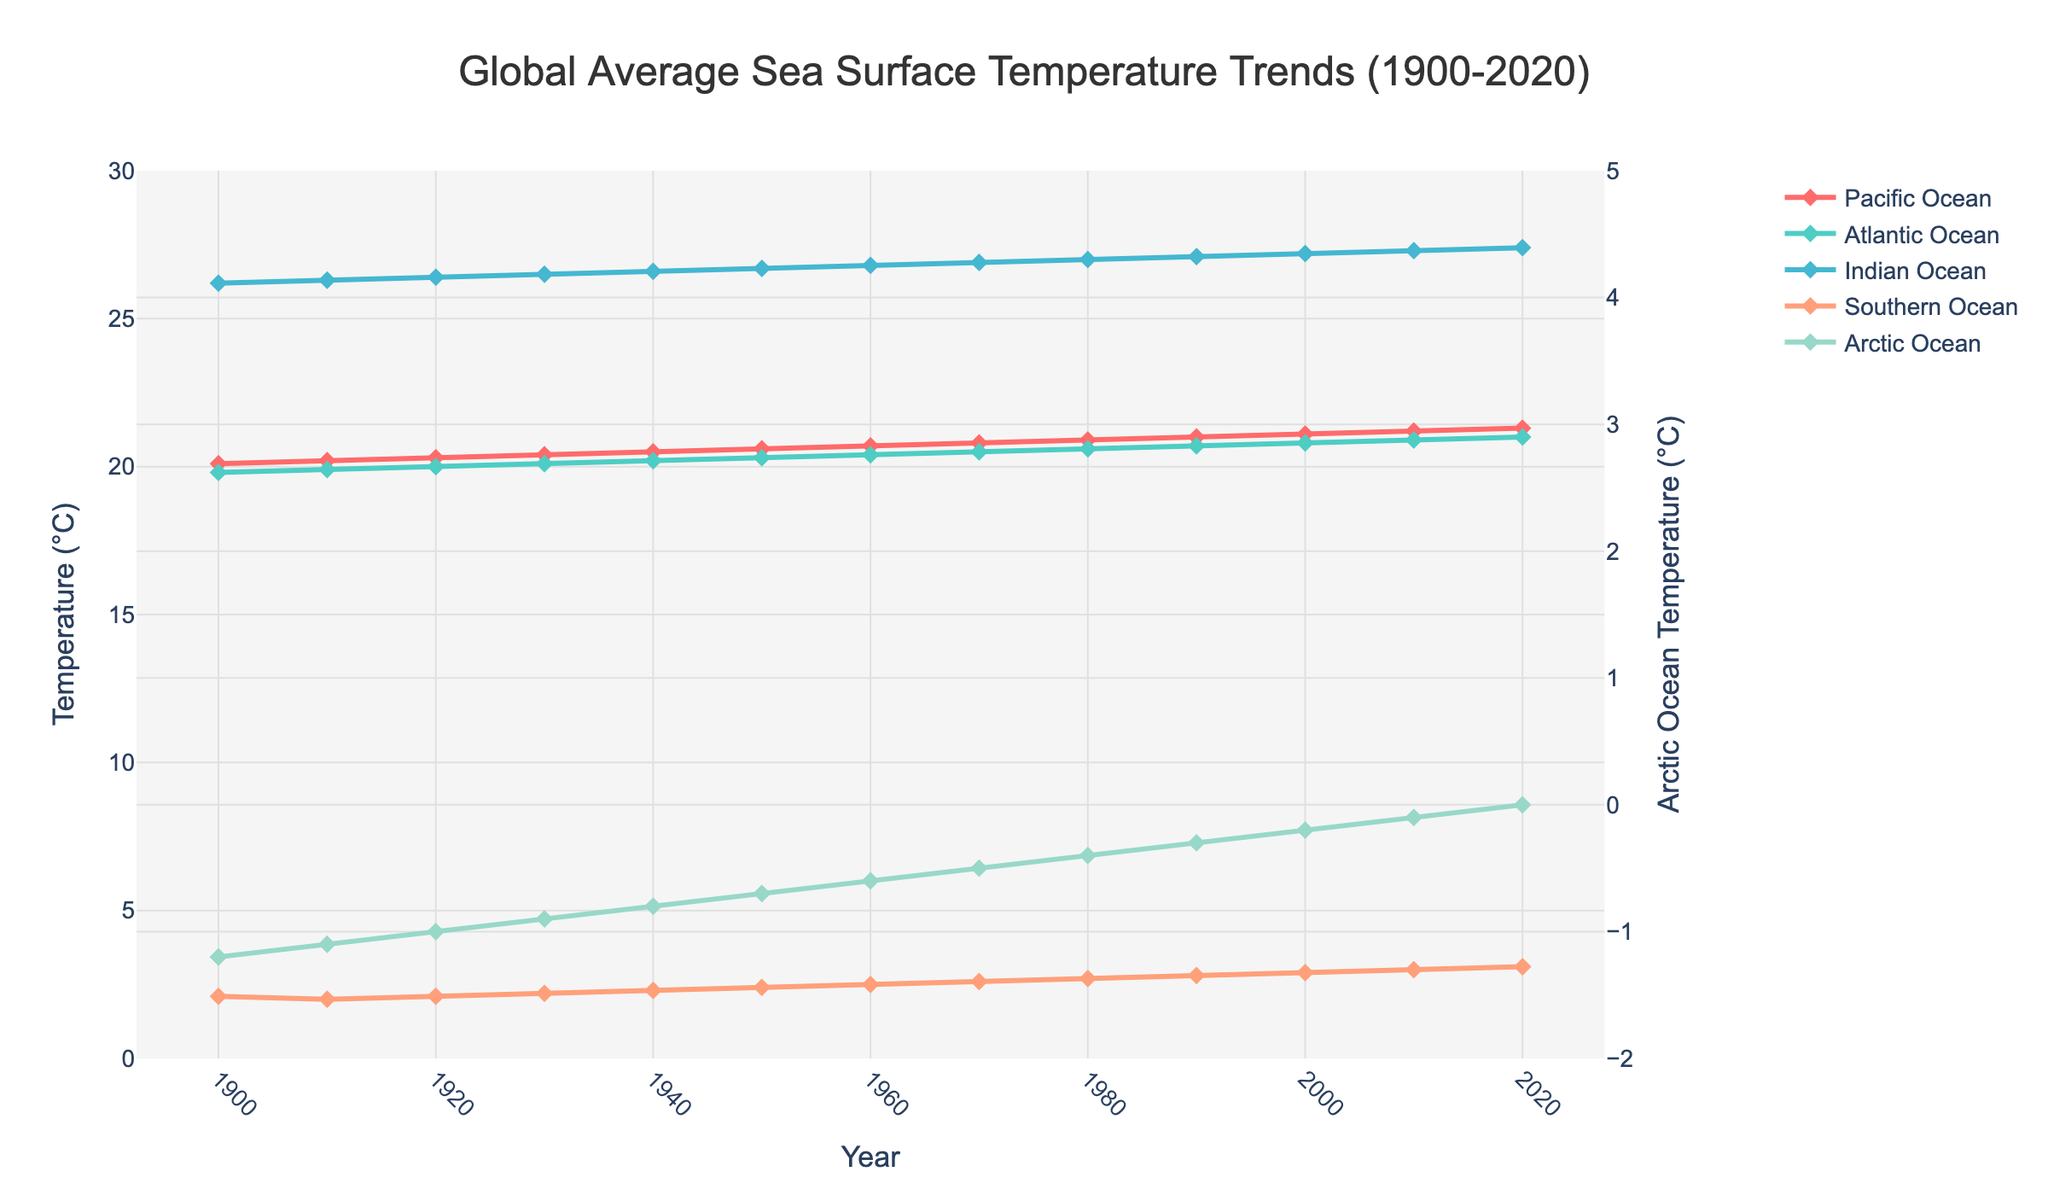Which ocean basin has the highest sea surface temperature increase from 1900 to 2020? Check the temperatures for all basins in both 1900 and 2020. Subtract the 2020 temperature from the 1900 temperature for each basin. The Indian Ocean shows an increase from 26.2°C to 27.4°C, which is 1.2°C, while other basins show lesser increases.
Answer: Indian Ocean Which ocean basin shows the least change in sea surface temperature from 1900 to 2020? Calculate the difference in temperature from 1900 to 2020 for each basin. The Arctic Ocean shows the least change with an increase from -1.2°C to 0°C, a difference of 1.2°C, which matches the smallest change among all oceans when compared with others.
Answer: Arctic Ocean (also has the smallest range) Which year did the Atlantic Ocean sea surface temperature surpass 20°C for the first time? Look at the Atlantic Ocean temperature trend and identify the first year the temperature exceeds 20°C. According to the data, it happened in 1920 when the temperature hits 20.0°C.
Answer: 1920 What is the average sea surface temperature for the Pacific Ocean across the entire dataset? Sum all the temperatures for the Pacific Ocean from 1900 to 2020 and then divide by the number of years (13). The data provided represents every 10 years, thus average = (20.1 + 20.2 + 20.3 + 20.4 + 20.5 + 20.6 + 20.7 + 20.8 + 20.9 + 21.0 + 21.1 + 21.2 + 21.3) / 13 = 270.1 / 13 = 20.777.
Answer: 20.78°C Which ocean basin has the steepest temperature increase based on visual slope? By observing the steepness of the temperature lines on the chart, the Southern Ocean has the steepest relative increase, showing a noticeable incline in its temperatures.
Answer: Southern Ocean In which year did the Arctic Ocean reach 0°C? Track the Arctic Ocean temperature trend and observe where it hits 0°C. According to the data, this occurs in 2020.
Answer: 2020 Which ocean shows the most stable temperature pattern over the century? "Stable" means minimal fluctuation or smooth gradient. The Pacific Ocean shows a steady increase with a smoother slope compared to the other oceans' trends.
Answer: Pacific Ocean How much did the Southern Ocean temperature increase between 1930 and 1970? Subtract the 1930 temperature from the 1970 temperature for the Southern Ocean. The difference is 2.6°C - 2.2°C = 0.4°C.
Answer: 0.4°C Comparing the year 2000, which ocean's temperature is less than 21°C? For the year 2000, list out the temperature of each ocean. The Atlantic Ocean registers 20.8°C, the Southern Ocean 2.9°C, and the Arctic Ocean -0.2°C have temperatures less than 21°C. The Pacific and Indian Oceans are above this threshold.
Answer: Atlantic, Southern, Arctic Oceans 